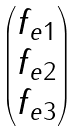Convert formula to latex. <formula><loc_0><loc_0><loc_500><loc_500>\begin{pmatrix} f _ { e 1 } \\ f _ { e 2 } \\ f _ { e 3 } \\ \end{pmatrix}</formula> 